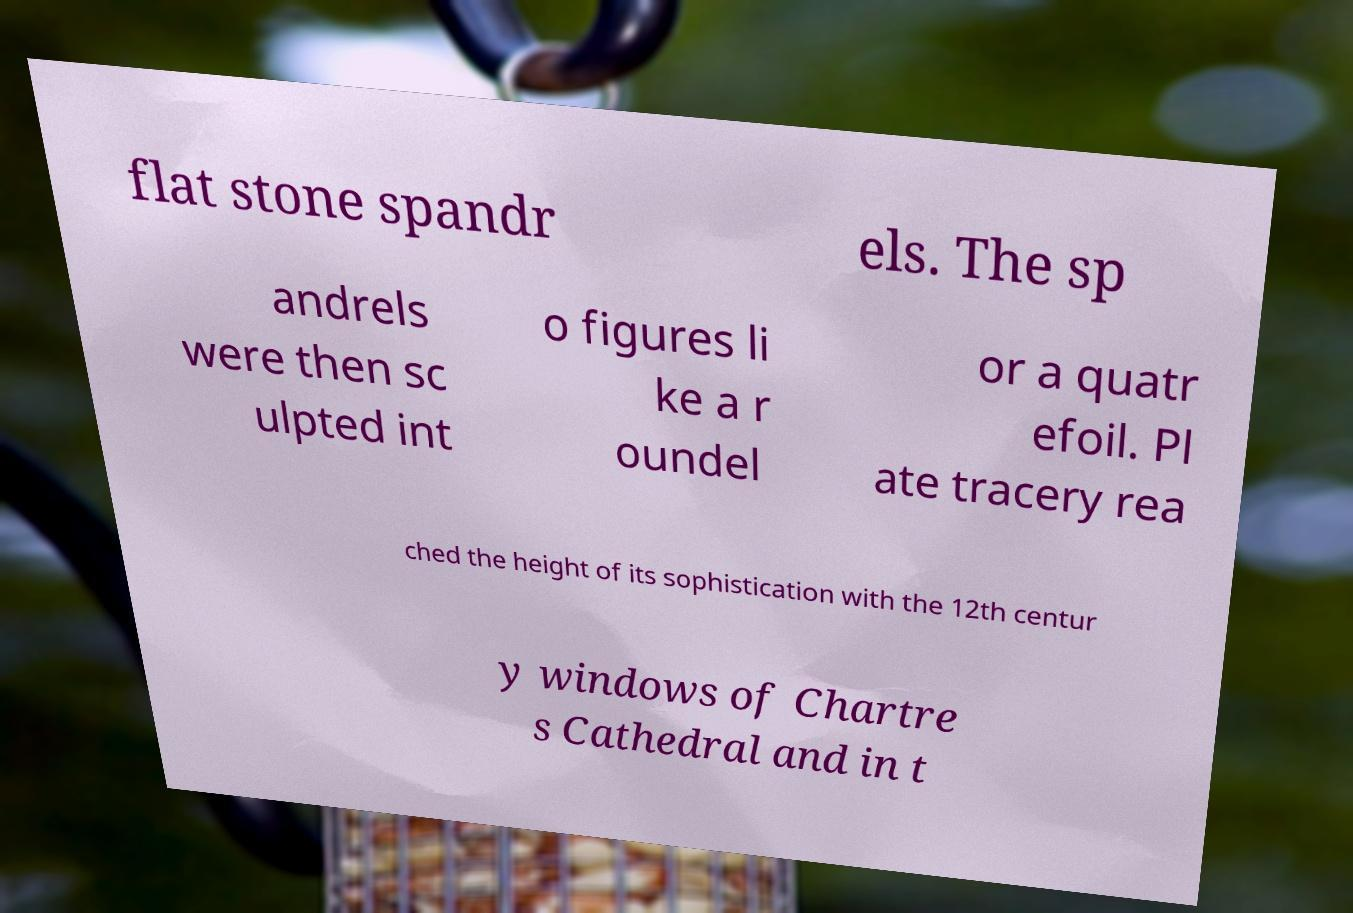For documentation purposes, I need the text within this image transcribed. Could you provide that? flat stone spandr els. The sp andrels were then sc ulpted int o figures li ke a r oundel or a quatr efoil. Pl ate tracery rea ched the height of its sophistication with the 12th centur y windows of Chartre s Cathedral and in t 